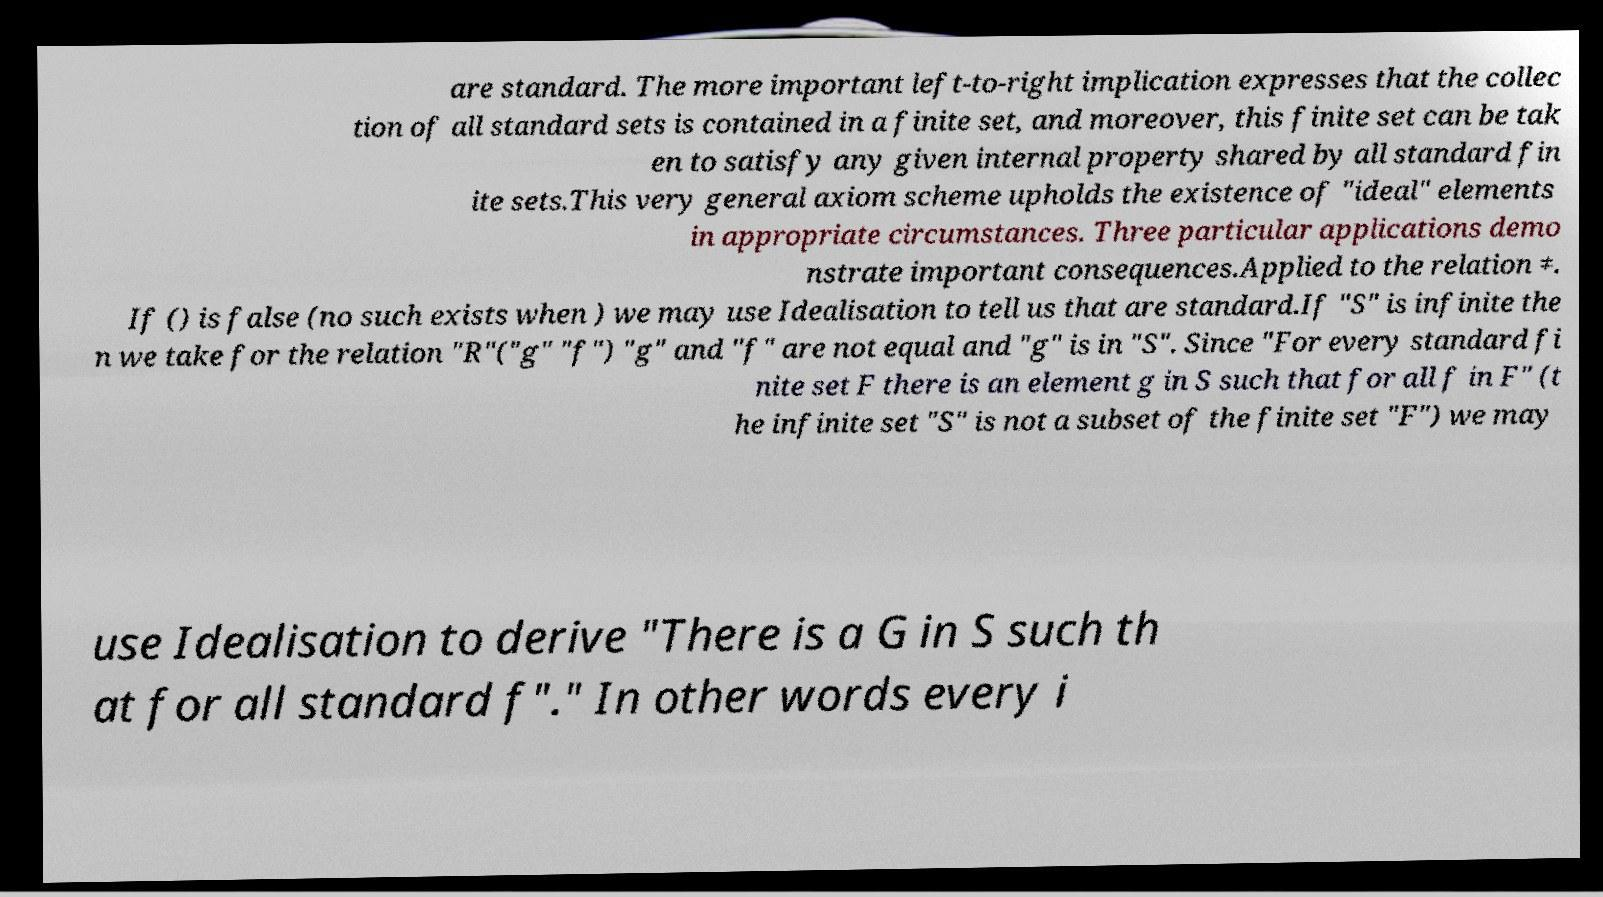Can you read and provide the text displayed in the image?This photo seems to have some interesting text. Can you extract and type it out for me? are standard. The more important left-to-right implication expresses that the collec tion of all standard sets is contained in a finite set, and moreover, this finite set can be tak en to satisfy any given internal property shared by all standard fin ite sets.This very general axiom scheme upholds the existence of "ideal" elements in appropriate circumstances. Three particular applications demo nstrate important consequences.Applied to the relation ≠. If () is false (no such exists when ) we may use Idealisation to tell us that are standard.If "S" is infinite the n we take for the relation "R"("g" "f") "g" and "f" are not equal and "g" is in "S". Since "For every standard fi nite set F there is an element g in S such that for all f in F" (t he infinite set "S" is not a subset of the finite set "F") we may use Idealisation to derive "There is a G in S such th at for all standard f"." In other words every i 